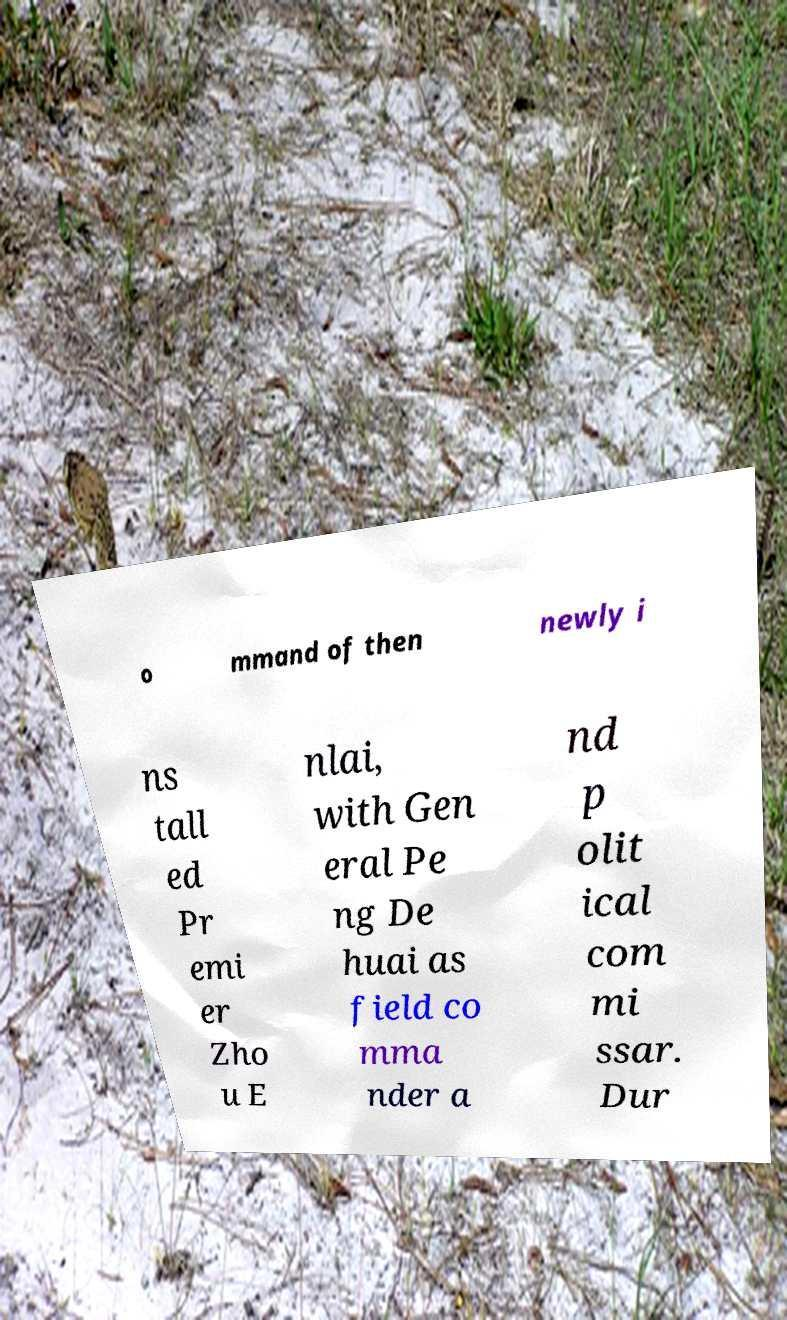Could you extract and type out the text from this image? o mmand of then newly i ns tall ed Pr emi er Zho u E nlai, with Gen eral Pe ng De huai as field co mma nder a nd p olit ical com mi ssar. Dur 